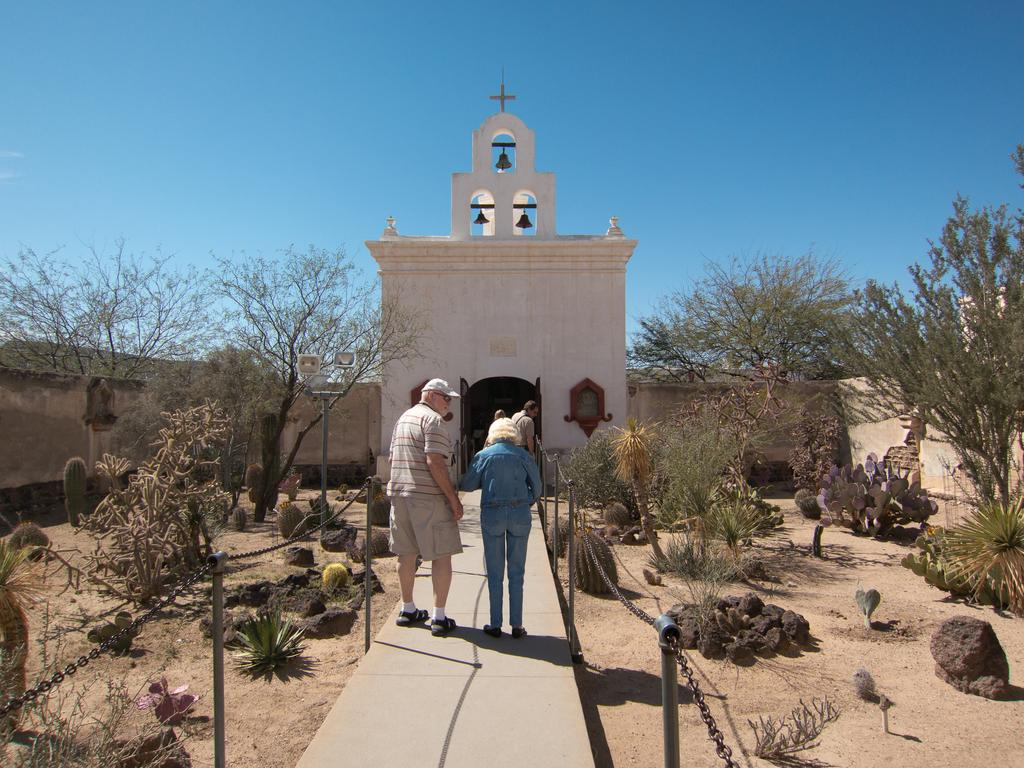What are the people in the image doing? The people in the image are walking on the pavement. What can be seen beside the pavement? There are trees and rocks beside the pavement. What is visible in the background of the image? There is a wall with a cross on it in the background of the image. How many apples are hanging from the trees beside the pavement? There are no apples visible in the image; only trees are mentioned. What type of spade is being used by the people walking on the pavement? There is no spade present in the image; the people are simply walking. 